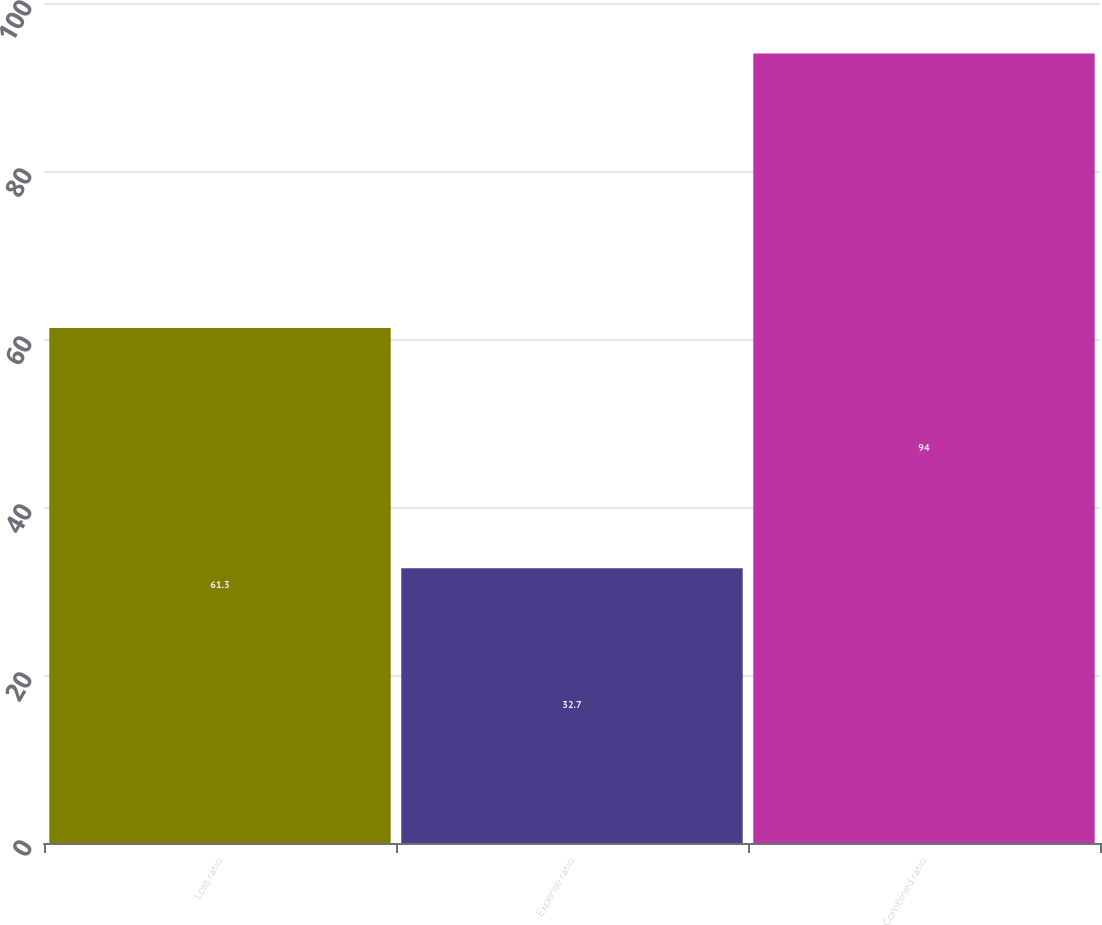<chart> <loc_0><loc_0><loc_500><loc_500><bar_chart><fcel>Loss ratio<fcel>Expense ratio<fcel>Combined ratio<nl><fcel>61.3<fcel>32.7<fcel>94<nl></chart> 